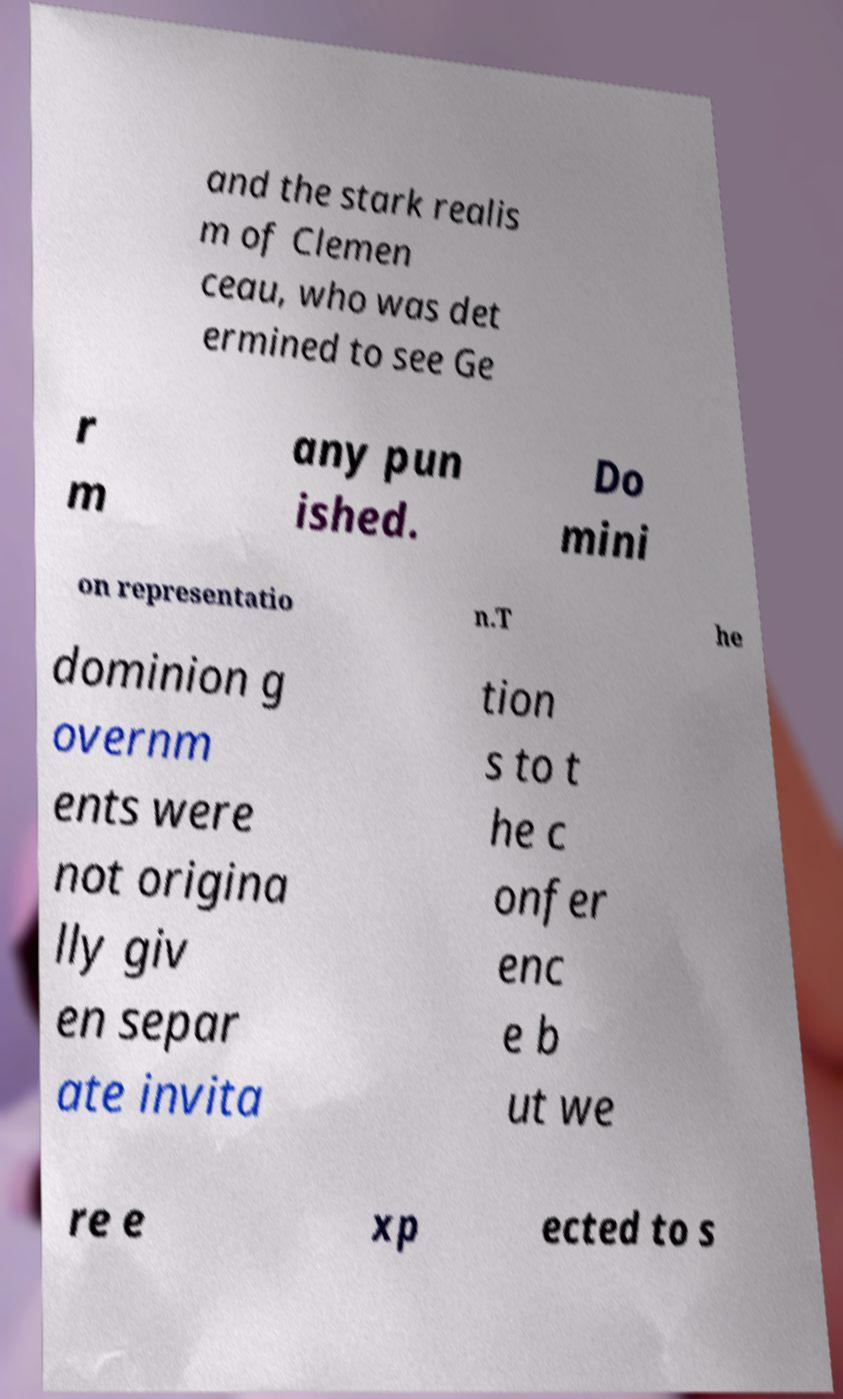What messages or text are displayed in this image? I need them in a readable, typed format. and the stark realis m of Clemen ceau, who was det ermined to see Ge r m any pun ished. Do mini on representatio n.T he dominion g overnm ents were not origina lly giv en separ ate invita tion s to t he c onfer enc e b ut we re e xp ected to s 